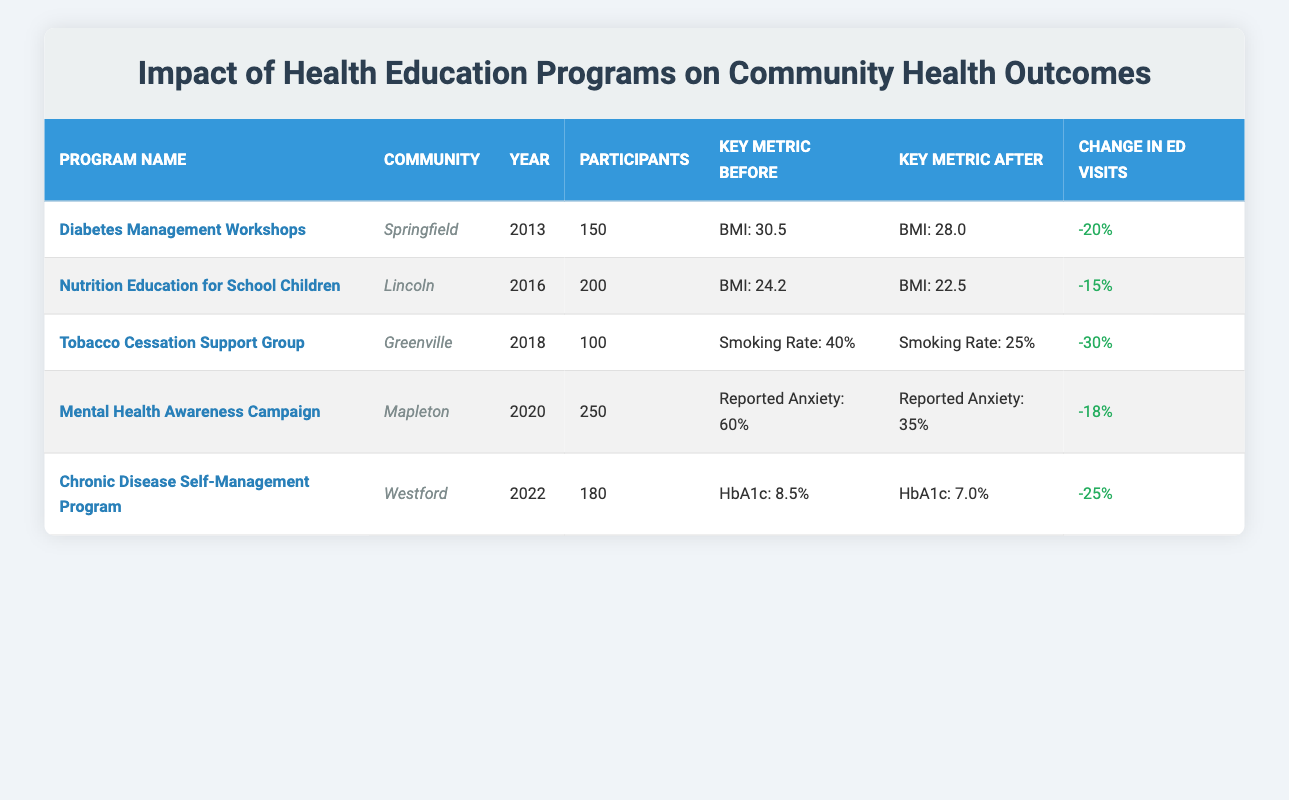What was the change in emergency department visits for the Tobacco Cessation Support Group program? The data shows that the change in emergency department visits for the Tobacco Cessation Support Group program in Greenville was a reduction of 30%.
Answer: -30% Which community had the highest number of participants in a health education program? Looking at the table, the Mental Health Awareness Campaign in Mapleton had the highest number of participants, with a total of 250 people attending.
Answer: Mapleton What was the average BMI change for participants in the Diabetes Management Workshops? The average BMI before the workshops was 30.5, and after it was 28.0. The change is calculated as 30.5 - 28.0 = 2.5.
Answer: 2.5 Did the Nutrition Education for School Children program lead to an increase in the hypertension rate? The data indicates that the hypertension rate decreased from 10% before the program to 5% after the program, confirming a decrease rather than an increase.
Answer: No What was the total number of participants across all health education programs listed? By summing the participants for each program: 150 (Diabetes) + 200 (Nutrition) + 100 (Tobacco) + 250 (Mental Health) + 180 (Chronic Disease) = 880 participants in total.
Answer: 880 What was the change in reported anxiety levels after the Mental Health Awareness Campaign? The reported anxiety levels decreased from 60% before the campaign to 35% after the campaign. The change is 60% - 35% = 25%.
Answer: 25% Did the Chronic Disease Self-Management Program have an effect on the average HbA1c levels? Yes, the average HbA1c levels decreased from 8.5% before the program to 7.0% after the program, indicating an improvement in health outcomes.
Answer: Yes Which health education program showed the greatest percentage reduction in emergency department visits? To find this, we look for the program with the highest negative percentage in the "Change in ED Visits" column. The Tobacco Cessation Support Group had the largest reduction at -30%.
Answer: Tobacco Cessation Support Group 